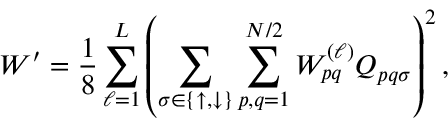Convert formula to latex. <formula><loc_0><loc_0><loc_500><loc_500>W ^ { \prime } = \frac { 1 } { 8 } \sum _ { \ell = 1 } ^ { L } \left ( \sum _ { \sigma \in \{ \uparrow , \downarrow \} } \sum _ { p , q = 1 } ^ { N / 2 } W _ { p q } ^ { ( \ell ) } Q _ { p q \sigma } \right ) ^ { 2 } ,</formula> 